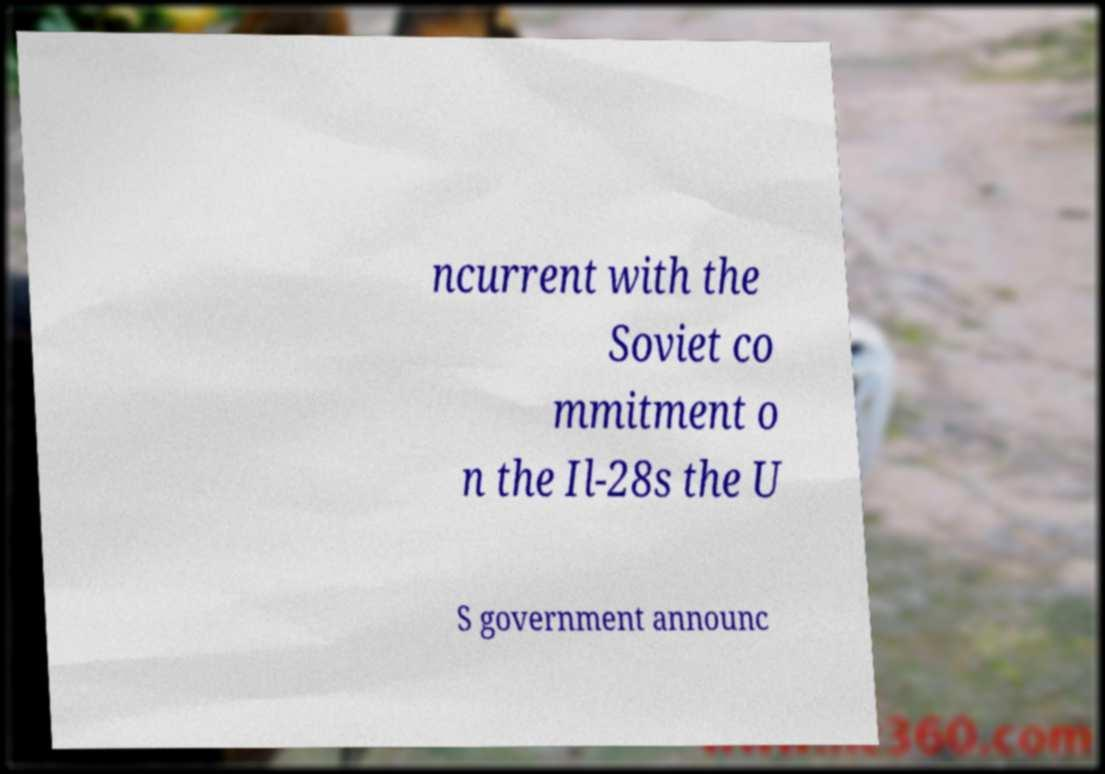Could you assist in decoding the text presented in this image and type it out clearly? ncurrent with the Soviet co mmitment o n the Il-28s the U S government announc 